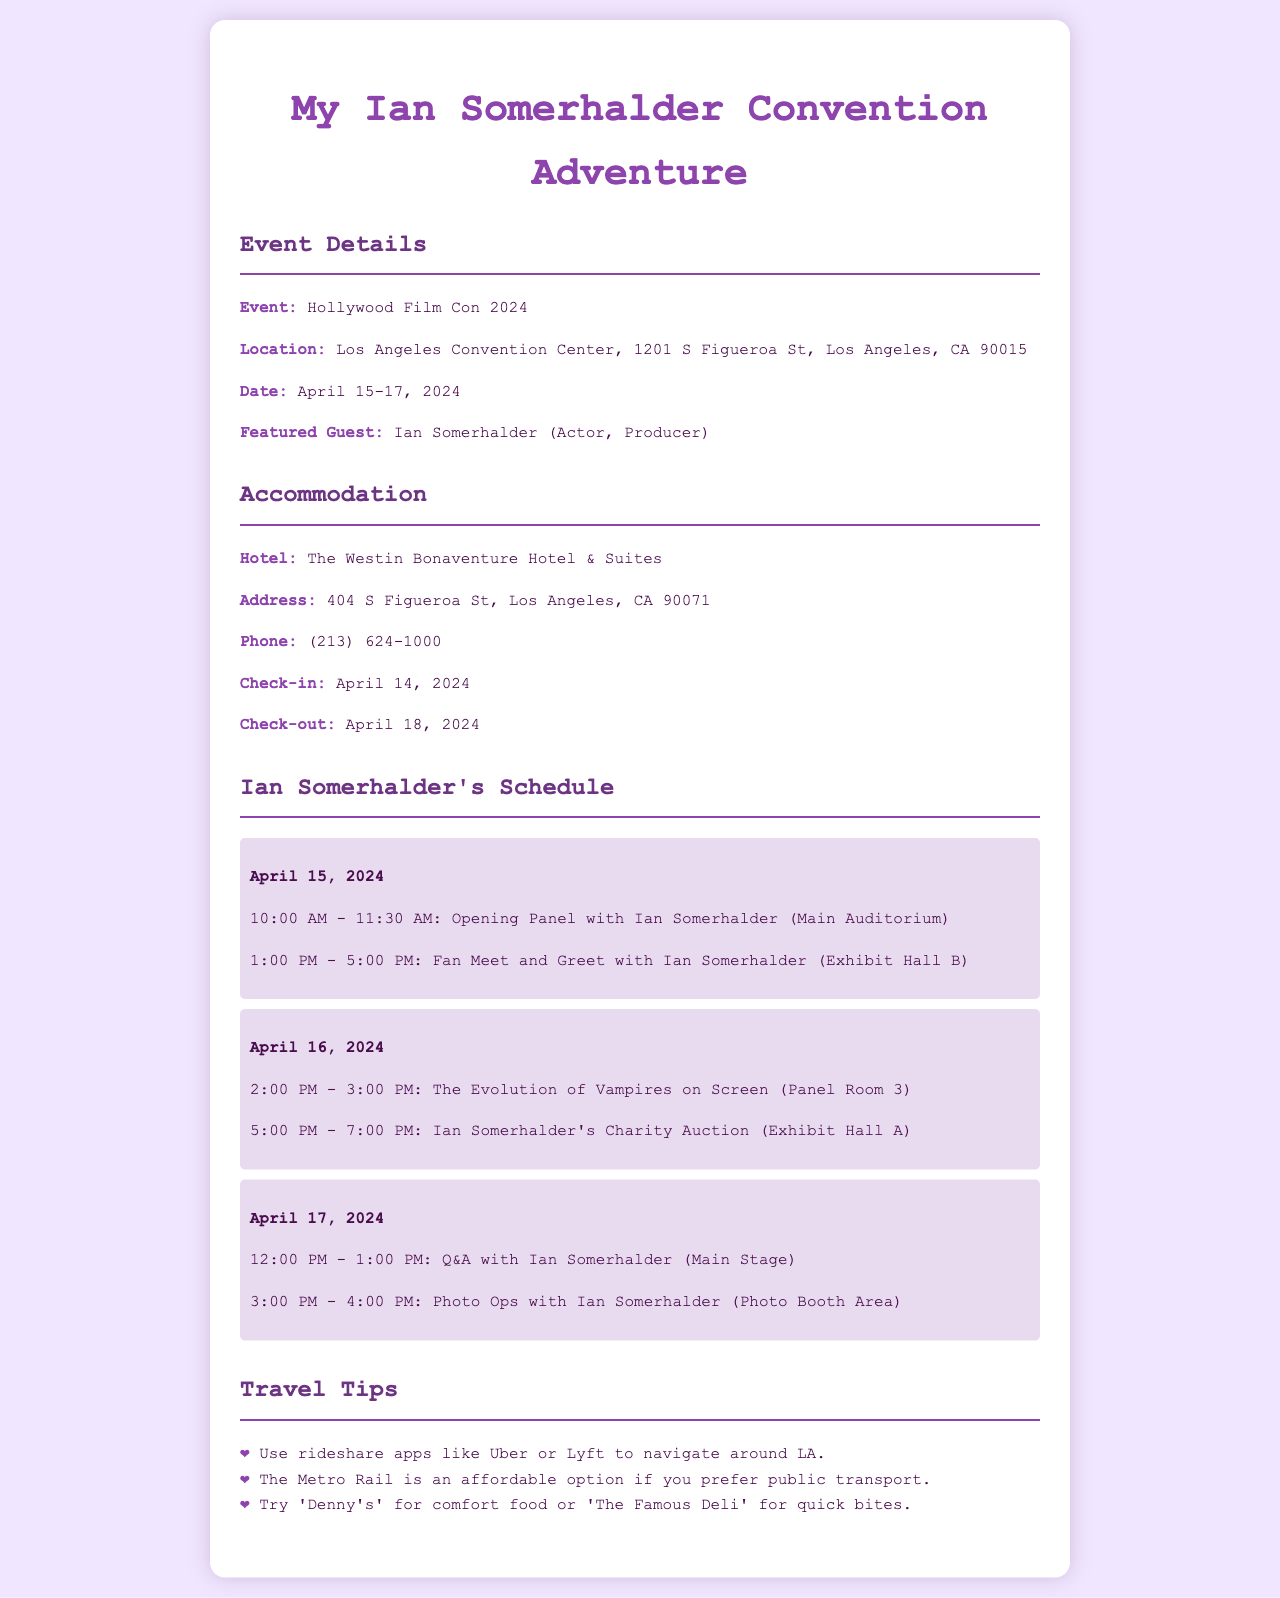What is the name of the event? The document explicitly mentions the event's name, which is "Hollywood Film Con 2024."
Answer: Hollywood Film Con 2024 Where is the convention located? The document provides the full address for the location of the event.
Answer: Los Angeles Convention Center, 1201 S Figueroa St, Los Angeles, CA 90015 What are the check-in and check-out dates for the hotel? The check-in and check-out dates can be found in the accommodation section of the document.
Answer: April 14, 2024 and April 18, 2024 How many days will the event take place? The document states the event is scheduled from April 15 to April 17, indicating the number of days.
Answer: Three days What time is the opening panel with Ian Somerhalder? The document details the schedule, including the time of the opening panel.
Answer: 10:00 AM - 11:30 AM How many panels are Ian Somerhalder participating in? The schedule lists specific panels, and counting them gives the total number Ian is participating in.
Answer: Three panels What is one travel tip mentioned in the document? The document includes a list of travel tips, and you can take any one from that list.
Answer: Use rideshare apps like Uber or Lyft to navigate around LA What is the name of the hotel for accommodation? The accommodation section of the document explicitly states the name of the hotel.
Answer: The Westin Bonaventure Hotel & Suites What type of event is hosted on April 16 with Ian Somerhalder? The schedule notes a specific type of event that is hosted on that day which informs about its nature.
Answer: Charity Auction 